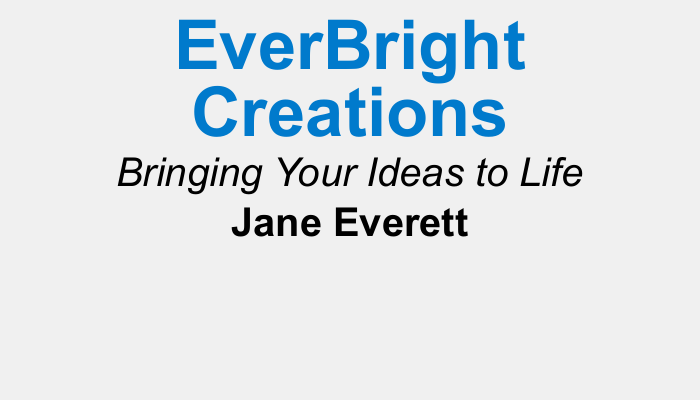what is the name of the business? The business name is prominently featured at the top of the document.
Answer: EverBright Creations who is the owner of the business? The owner's name is clearly indicated beneath the business name.
Answer: Jane Everett what is the tagline of the business? The tagline summarizes the business's mission and is placed right below the name.
Answer: Bringing Your Ideas to Life what is the phone number listed on the card? The phone number is provided in the contact information section.
Answer: 123-456-7890 where is the business located? The address is specified in the contact details on the card.
Answer: 123 Elm Street, Springfield, IL, 62701 which social media platform is mentioned? The card includes links to platforms for engagement with clients.
Answer: Instagram what services does the business specialize in? The business description provides insight into its focus area.
Answer: custom graphic design and branding services what is the purpose of the card? The overall aim of the card is indicated in the final lines.
Answer: marketing the business how does the design of the card reflect the business's theme? The use of colors and layout contributes to the overall branding strategy.
Answer: colorful and vibrant 